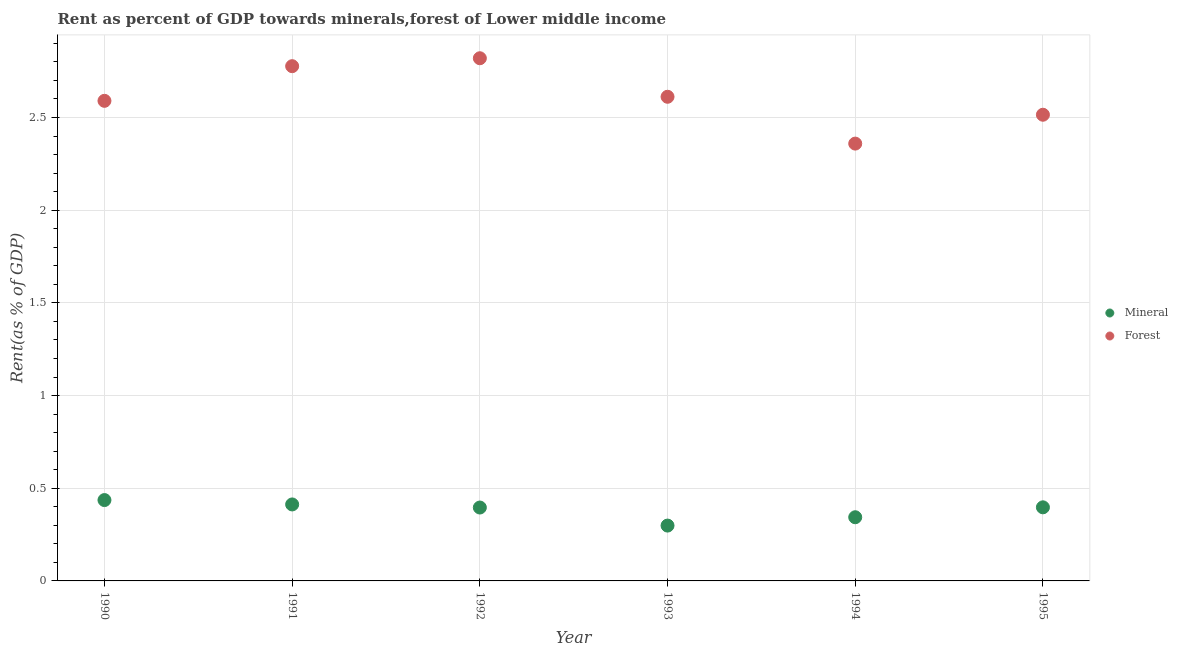How many different coloured dotlines are there?
Your response must be concise. 2. What is the mineral rent in 1990?
Provide a succinct answer. 0.44. Across all years, what is the maximum forest rent?
Ensure brevity in your answer.  2.82. Across all years, what is the minimum mineral rent?
Give a very brief answer. 0.3. In which year was the mineral rent maximum?
Offer a terse response. 1990. In which year was the forest rent minimum?
Provide a short and direct response. 1994. What is the total mineral rent in the graph?
Ensure brevity in your answer.  2.28. What is the difference between the mineral rent in 1992 and that in 1993?
Keep it short and to the point. 0.1. What is the difference between the forest rent in 1992 and the mineral rent in 1995?
Your answer should be very brief. 2.42. What is the average forest rent per year?
Your response must be concise. 2.61. In the year 1995, what is the difference between the forest rent and mineral rent?
Provide a short and direct response. 2.12. What is the ratio of the mineral rent in 1993 to that in 1994?
Give a very brief answer. 0.87. Is the forest rent in 1992 less than that in 1995?
Keep it short and to the point. No. What is the difference between the highest and the second highest forest rent?
Ensure brevity in your answer.  0.04. What is the difference between the highest and the lowest mineral rent?
Offer a very short reply. 0.14. Is the sum of the mineral rent in 1993 and 1995 greater than the maximum forest rent across all years?
Make the answer very short. No. Does the forest rent monotonically increase over the years?
Your response must be concise. No. Is the forest rent strictly less than the mineral rent over the years?
Ensure brevity in your answer.  No. How many dotlines are there?
Offer a terse response. 2. What is the difference between two consecutive major ticks on the Y-axis?
Give a very brief answer. 0.5. Are the values on the major ticks of Y-axis written in scientific E-notation?
Make the answer very short. No. How are the legend labels stacked?
Ensure brevity in your answer.  Vertical. What is the title of the graph?
Ensure brevity in your answer.  Rent as percent of GDP towards minerals,forest of Lower middle income. Does "Exports" appear as one of the legend labels in the graph?
Keep it short and to the point. No. What is the label or title of the Y-axis?
Keep it short and to the point. Rent(as % of GDP). What is the Rent(as % of GDP) of Mineral in 1990?
Give a very brief answer. 0.44. What is the Rent(as % of GDP) in Forest in 1990?
Provide a succinct answer. 2.59. What is the Rent(as % of GDP) of Mineral in 1991?
Your response must be concise. 0.41. What is the Rent(as % of GDP) of Forest in 1991?
Provide a succinct answer. 2.78. What is the Rent(as % of GDP) in Mineral in 1992?
Your answer should be very brief. 0.4. What is the Rent(as % of GDP) in Forest in 1992?
Make the answer very short. 2.82. What is the Rent(as % of GDP) in Mineral in 1993?
Your response must be concise. 0.3. What is the Rent(as % of GDP) of Forest in 1993?
Your answer should be compact. 2.61. What is the Rent(as % of GDP) in Mineral in 1994?
Your response must be concise. 0.34. What is the Rent(as % of GDP) of Forest in 1994?
Ensure brevity in your answer.  2.36. What is the Rent(as % of GDP) of Mineral in 1995?
Make the answer very short. 0.4. What is the Rent(as % of GDP) of Forest in 1995?
Provide a succinct answer. 2.51. Across all years, what is the maximum Rent(as % of GDP) of Mineral?
Offer a terse response. 0.44. Across all years, what is the maximum Rent(as % of GDP) of Forest?
Offer a terse response. 2.82. Across all years, what is the minimum Rent(as % of GDP) in Mineral?
Your response must be concise. 0.3. Across all years, what is the minimum Rent(as % of GDP) in Forest?
Your answer should be compact. 2.36. What is the total Rent(as % of GDP) in Mineral in the graph?
Give a very brief answer. 2.28. What is the total Rent(as % of GDP) of Forest in the graph?
Provide a succinct answer. 15.67. What is the difference between the Rent(as % of GDP) in Mineral in 1990 and that in 1991?
Provide a succinct answer. 0.02. What is the difference between the Rent(as % of GDP) of Forest in 1990 and that in 1991?
Ensure brevity in your answer.  -0.19. What is the difference between the Rent(as % of GDP) in Mineral in 1990 and that in 1992?
Make the answer very short. 0.04. What is the difference between the Rent(as % of GDP) of Forest in 1990 and that in 1992?
Your response must be concise. -0.23. What is the difference between the Rent(as % of GDP) in Mineral in 1990 and that in 1993?
Your answer should be very brief. 0.14. What is the difference between the Rent(as % of GDP) in Forest in 1990 and that in 1993?
Ensure brevity in your answer.  -0.02. What is the difference between the Rent(as % of GDP) in Mineral in 1990 and that in 1994?
Your answer should be very brief. 0.09. What is the difference between the Rent(as % of GDP) in Forest in 1990 and that in 1994?
Make the answer very short. 0.23. What is the difference between the Rent(as % of GDP) in Mineral in 1990 and that in 1995?
Your answer should be very brief. 0.04. What is the difference between the Rent(as % of GDP) in Forest in 1990 and that in 1995?
Your response must be concise. 0.07. What is the difference between the Rent(as % of GDP) of Mineral in 1991 and that in 1992?
Provide a short and direct response. 0.02. What is the difference between the Rent(as % of GDP) in Forest in 1991 and that in 1992?
Give a very brief answer. -0.04. What is the difference between the Rent(as % of GDP) in Mineral in 1991 and that in 1993?
Your answer should be compact. 0.11. What is the difference between the Rent(as % of GDP) of Forest in 1991 and that in 1993?
Your response must be concise. 0.17. What is the difference between the Rent(as % of GDP) of Mineral in 1991 and that in 1994?
Offer a very short reply. 0.07. What is the difference between the Rent(as % of GDP) of Forest in 1991 and that in 1994?
Keep it short and to the point. 0.42. What is the difference between the Rent(as % of GDP) of Mineral in 1991 and that in 1995?
Offer a terse response. 0.02. What is the difference between the Rent(as % of GDP) in Forest in 1991 and that in 1995?
Give a very brief answer. 0.26. What is the difference between the Rent(as % of GDP) of Mineral in 1992 and that in 1993?
Provide a short and direct response. 0.1. What is the difference between the Rent(as % of GDP) of Forest in 1992 and that in 1993?
Provide a short and direct response. 0.21. What is the difference between the Rent(as % of GDP) of Mineral in 1992 and that in 1994?
Offer a very short reply. 0.05. What is the difference between the Rent(as % of GDP) in Forest in 1992 and that in 1994?
Ensure brevity in your answer.  0.46. What is the difference between the Rent(as % of GDP) of Mineral in 1992 and that in 1995?
Give a very brief answer. -0. What is the difference between the Rent(as % of GDP) of Forest in 1992 and that in 1995?
Ensure brevity in your answer.  0.3. What is the difference between the Rent(as % of GDP) of Mineral in 1993 and that in 1994?
Make the answer very short. -0.04. What is the difference between the Rent(as % of GDP) of Forest in 1993 and that in 1994?
Provide a short and direct response. 0.25. What is the difference between the Rent(as % of GDP) of Mineral in 1993 and that in 1995?
Your answer should be compact. -0.1. What is the difference between the Rent(as % of GDP) of Forest in 1993 and that in 1995?
Keep it short and to the point. 0.1. What is the difference between the Rent(as % of GDP) of Mineral in 1994 and that in 1995?
Make the answer very short. -0.05. What is the difference between the Rent(as % of GDP) of Forest in 1994 and that in 1995?
Give a very brief answer. -0.16. What is the difference between the Rent(as % of GDP) of Mineral in 1990 and the Rent(as % of GDP) of Forest in 1991?
Provide a succinct answer. -2.34. What is the difference between the Rent(as % of GDP) of Mineral in 1990 and the Rent(as % of GDP) of Forest in 1992?
Ensure brevity in your answer.  -2.38. What is the difference between the Rent(as % of GDP) in Mineral in 1990 and the Rent(as % of GDP) in Forest in 1993?
Give a very brief answer. -2.18. What is the difference between the Rent(as % of GDP) of Mineral in 1990 and the Rent(as % of GDP) of Forest in 1994?
Provide a succinct answer. -1.92. What is the difference between the Rent(as % of GDP) of Mineral in 1990 and the Rent(as % of GDP) of Forest in 1995?
Offer a very short reply. -2.08. What is the difference between the Rent(as % of GDP) in Mineral in 1991 and the Rent(as % of GDP) in Forest in 1992?
Make the answer very short. -2.41. What is the difference between the Rent(as % of GDP) of Mineral in 1991 and the Rent(as % of GDP) of Forest in 1993?
Make the answer very short. -2.2. What is the difference between the Rent(as % of GDP) of Mineral in 1991 and the Rent(as % of GDP) of Forest in 1994?
Ensure brevity in your answer.  -1.95. What is the difference between the Rent(as % of GDP) in Mineral in 1991 and the Rent(as % of GDP) in Forest in 1995?
Offer a terse response. -2.1. What is the difference between the Rent(as % of GDP) of Mineral in 1992 and the Rent(as % of GDP) of Forest in 1993?
Your answer should be compact. -2.22. What is the difference between the Rent(as % of GDP) of Mineral in 1992 and the Rent(as % of GDP) of Forest in 1994?
Your response must be concise. -1.96. What is the difference between the Rent(as % of GDP) of Mineral in 1992 and the Rent(as % of GDP) of Forest in 1995?
Your response must be concise. -2.12. What is the difference between the Rent(as % of GDP) in Mineral in 1993 and the Rent(as % of GDP) in Forest in 1994?
Your answer should be compact. -2.06. What is the difference between the Rent(as % of GDP) in Mineral in 1993 and the Rent(as % of GDP) in Forest in 1995?
Give a very brief answer. -2.22. What is the difference between the Rent(as % of GDP) in Mineral in 1994 and the Rent(as % of GDP) in Forest in 1995?
Your answer should be very brief. -2.17. What is the average Rent(as % of GDP) in Mineral per year?
Your answer should be compact. 0.38. What is the average Rent(as % of GDP) of Forest per year?
Keep it short and to the point. 2.61. In the year 1990, what is the difference between the Rent(as % of GDP) in Mineral and Rent(as % of GDP) in Forest?
Give a very brief answer. -2.15. In the year 1991, what is the difference between the Rent(as % of GDP) of Mineral and Rent(as % of GDP) of Forest?
Make the answer very short. -2.36. In the year 1992, what is the difference between the Rent(as % of GDP) of Mineral and Rent(as % of GDP) of Forest?
Make the answer very short. -2.42. In the year 1993, what is the difference between the Rent(as % of GDP) in Mineral and Rent(as % of GDP) in Forest?
Provide a short and direct response. -2.31. In the year 1994, what is the difference between the Rent(as % of GDP) of Mineral and Rent(as % of GDP) of Forest?
Your answer should be very brief. -2.02. In the year 1995, what is the difference between the Rent(as % of GDP) of Mineral and Rent(as % of GDP) of Forest?
Offer a terse response. -2.12. What is the ratio of the Rent(as % of GDP) in Mineral in 1990 to that in 1991?
Provide a succinct answer. 1.06. What is the ratio of the Rent(as % of GDP) in Forest in 1990 to that in 1991?
Keep it short and to the point. 0.93. What is the ratio of the Rent(as % of GDP) in Mineral in 1990 to that in 1992?
Keep it short and to the point. 1.1. What is the ratio of the Rent(as % of GDP) in Forest in 1990 to that in 1992?
Offer a terse response. 0.92. What is the ratio of the Rent(as % of GDP) of Mineral in 1990 to that in 1993?
Make the answer very short. 1.46. What is the ratio of the Rent(as % of GDP) in Mineral in 1990 to that in 1994?
Ensure brevity in your answer.  1.27. What is the ratio of the Rent(as % of GDP) of Forest in 1990 to that in 1994?
Keep it short and to the point. 1.1. What is the ratio of the Rent(as % of GDP) in Mineral in 1990 to that in 1995?
Provide a short and direct response. 1.1. What is the ratio of the Rent(as % of GDP) of Forest in 1990 to that in 1995?
Offer a very short reply. 1.03. What is the ratio of the Rent(as % of GDP) in Mineral in 1991 to that in 1992?
Your answer should be compact. 1.04. What is the ratio of the Rent(as % of GDP) in Forest in 1991 to that in 1992?
Your answer should be compact. 0.98. What is the ratio of the Rent(as % of GDP) in Mineral in 1991 to that in 1993?
Keep it short and to the point. 1.38. What is the ratio of the Rent(as % of GDP) of Forest in 1991 to that in 1993?
Offer a terse response. 1.06. What is the ratio of the Rent(as % of GDP) of Mineral in 1991 to that in 1994?
Provide a succinct answer. 1.2. What is the ratio of the Rent(as % of GDP) of Forest in 1991 to that in 1994?
Give a very brief answer. 1.18. What is the ratio of the Rent(as % of GDP) of Mineral in 1991 to that in 1995?
Provide a short and direct response. 1.04. What is the ratio of the Rent(as % of GDP) of Forest in 1991 to that in 1995?
Your answer should be very brief. 1.1. What is the ratio of the Rent(as % of GDP) of Mineral in 1992 to that in 1993?
Offer a very short reply. 1.33. What is the ratio of the Rent(as % of GDP) of Forest in 1992 to that in 1993?
Your answer should be compact. 1.08. What is the ratio of the Rent(as % of GDP) in Mineral in 1992 to that in 1994?
Ensure brevity in your answer.  1.15. What is the ratio of the Rent(as % of GDP) of Forest in 1992 to that in 1994?
Give a very brief answer. 1.2. What is the ratio of the Rent(as % of GDP) of Forest in 1992 to that in 1995?
Give a very brief answer. 1.12. What is the ratio of the Rent(as % of GDP) in Mineral in 1993 to that in 1994?
Ensure brevity in your answer.  0.87. What is the ratio of the Rent(as % of GDP) of Forest in 1993 to that in 1994?
Your answer should be very brief. 1.11. What is the ratio of the Rent(as % of GDP) of Mineral in 1993 to that in 1995?
Your answer should be very brief. 0.75. What is the ratio of the Rent(as % of GDP) in Mineral in 1994 to that in 1995?
Give a very brief answer. 0.87. What is the ratio of the Rent(as % of GDP) of Forest in 1994 to that in 1995?
Your answer should be very brief. 0.94. What is the difference between the highest and the second highest Rent(as % of GDP) of Mineral?
Give a very brief answer. 0.02. What is the difference between the highest and the second highest Rent(as % of GDP) of Forest?
Provide a short and direct response. 0.04. What is the difference between the highest and the lowest Rent(as % of GDP) of Mineral?
Provide a short and direct response. 0.14. What is the difference between the highest and the lowest Rent(as % of GDP) of Forest?
Provide a short and direct response. 0.46. 